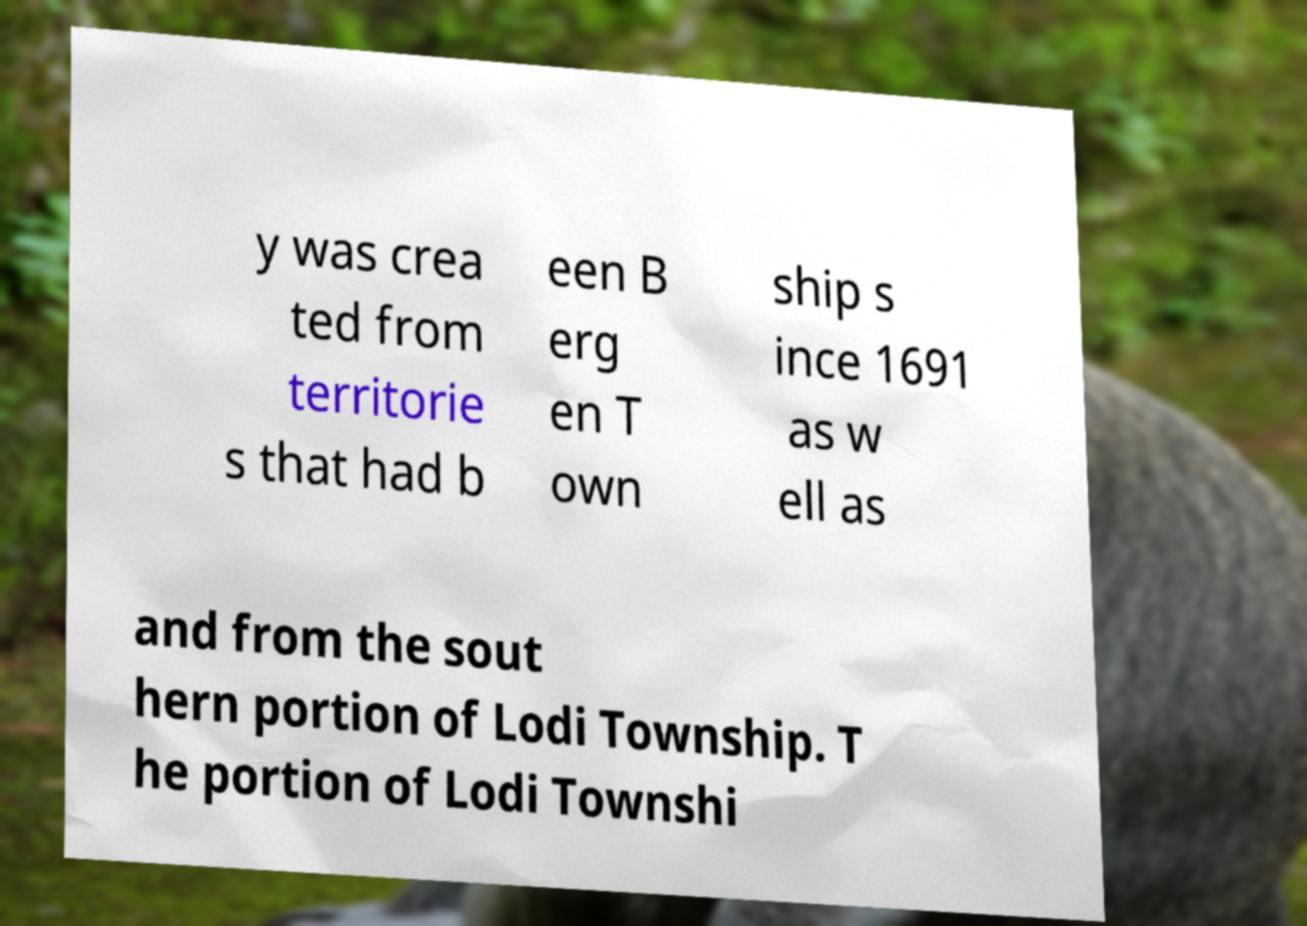Can you read and provide the text displayed in the image?This photo seems to have some interesting text. Can you extract and type it out for me? y was crea ted from territorie s that had b een B erg en T own ship s ince 1691 as w ell as and from the sout hern portion of Lodi Township. T he portion of Lodi Townshi 